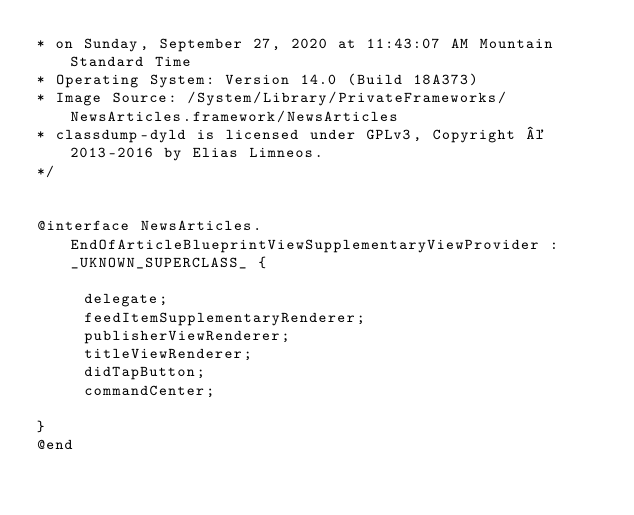<code> <loc_0><loc_0><loc_500><loc_500><_C_>* on Sunday, September 27, 2020 at 11:43:07 AM Mountain Standard Time
* Operating System: Version 14.0 (Build 18A373)
* Image Source: /System/Library/PrivateFrameworks/NewsArticles.framework/NewsArticles
* classdump-dyld is licensed under GPLv3, Copyright © 2013-2016 by Elias Limneos.
*/


@interface NewsArticles.EndOfArticleBlueprintViewSupplementaryViewProvider : _UKNOWN_SUPERCLASS_ {

	 delegate;
	 feedItemSupplementaryRenderer;
	 publisherViewRenderer;
	 titleViewRenderer;
	 didTapButton;
	 commandCenter;

}
@end

</code> 